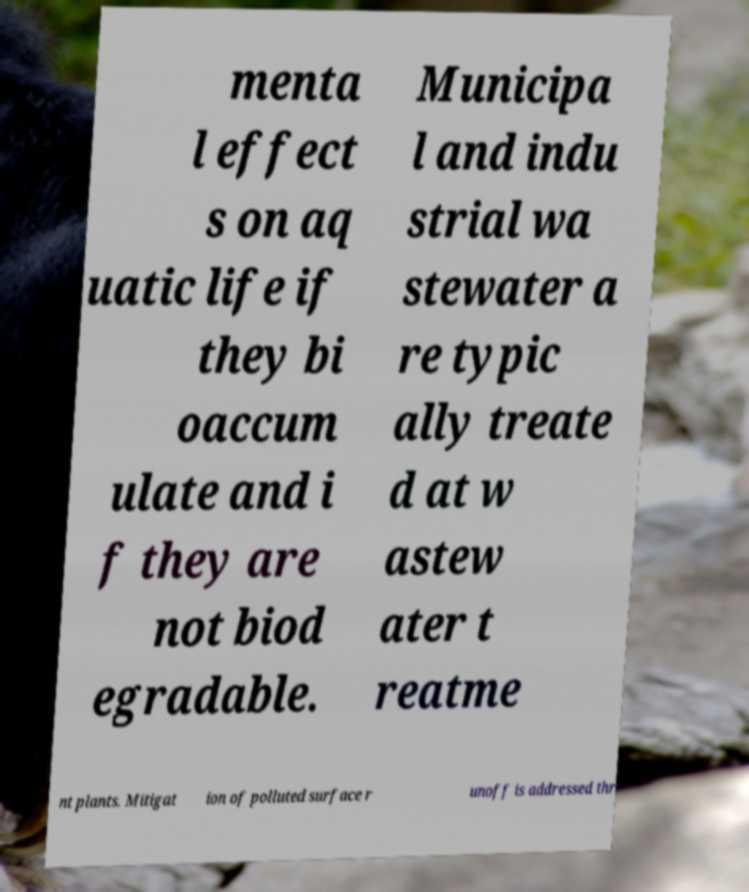Please identify and transcribe the text found in this image. menta l effect s on aq uatic life if they bi oaccum ulate and i f they are not biod egradable. Municipa l and indu strial wa stewater a re typic ally treate d at w astew ater t reatme nt plants. Mitigat ion of polluted surface r unoff is addressed thr 